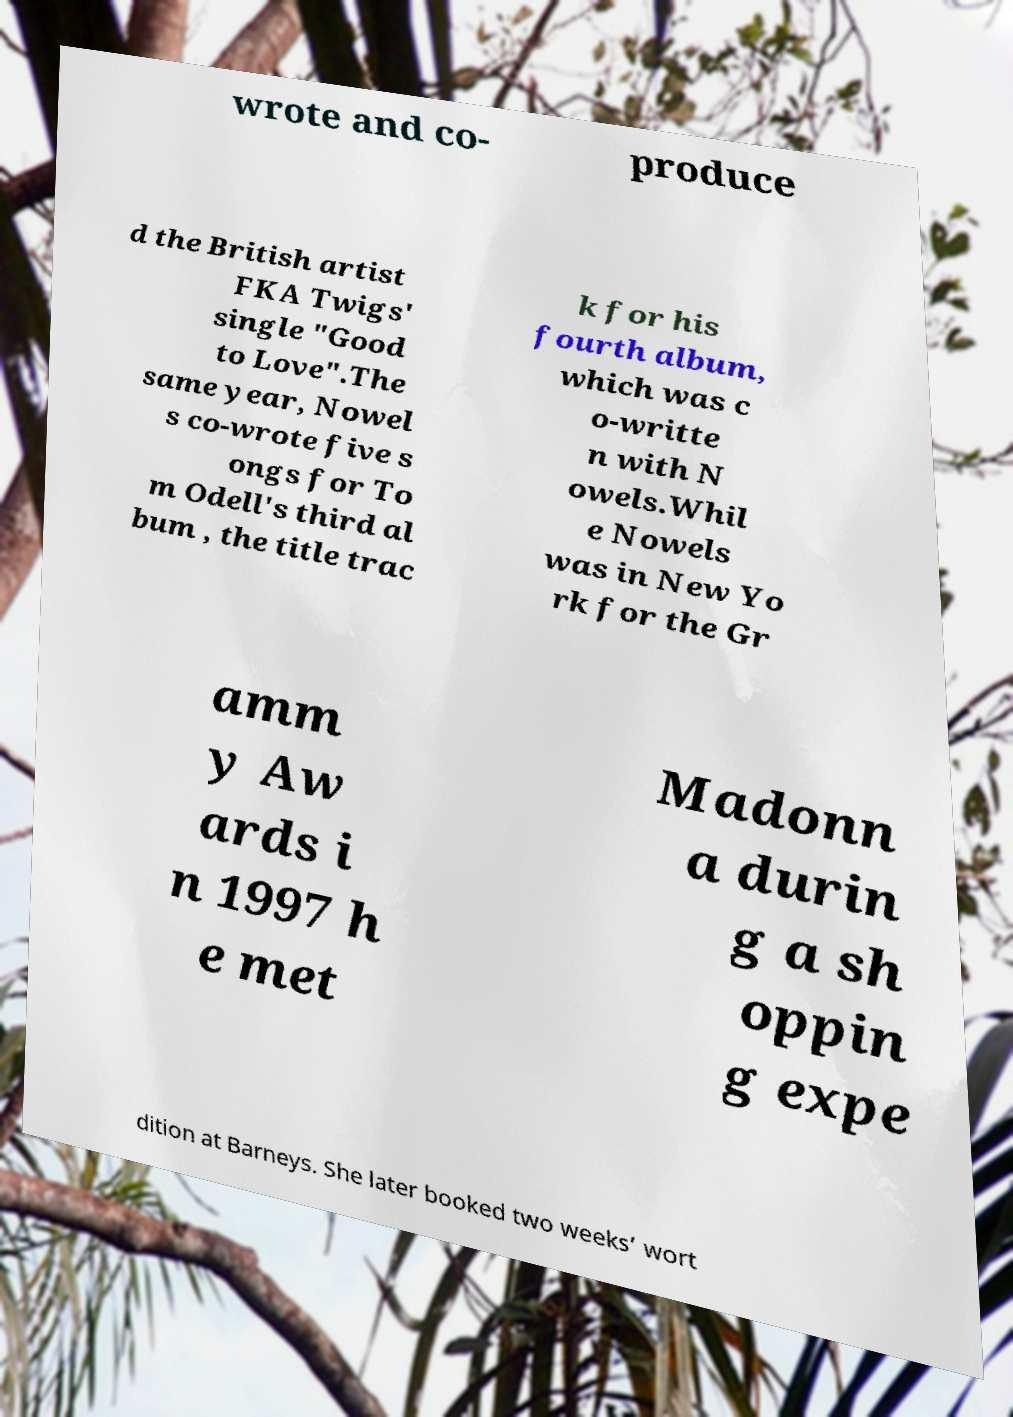Please identify and transcribe the text found in this image. wrote and co- produce d the British artist FKA Twigs' single "Good to Love".The same year, Nowel s co-wrote five s ongs for To m Odell's third al bum , the title trac k for his fourth album, which was c o-writte n with N owels.Whil e Nowels was in New Yo rk for the Gr amm y Aw ards i n 1997 h e met Madonn a durin g a sh oppin g expe dition at Barneys. She later booked two weeks’ wort 